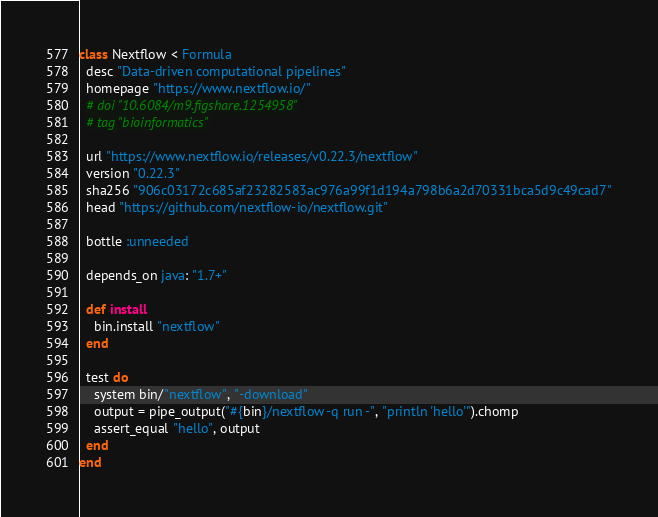<code> <loc_0><loc_0><loc_500><loc_500><_Ruby_>class Nextflow < Formula
  desc "Data-driven computational pipelines"
  homepage "https://www.nextflow.io/"
  # doi "10.6084/m9.figshare.1254958"
  # tag "bioinformatics"

  url "https://www.nextflow.io/releases/v0.22.3/nextflow"
  version "0.22.3"
  sha256 "906c03172c685af23282583ac976a99f1d194a798b6a2d70331bca5d9c49cad7"
  head "https://github.com/nextflow-io/nextflow.git"

  bottle :unneeded

  depends_on java: "1.7+"

  def install
    bin.install "nextflow"
  end

  test do
    system bin/"nextflow", "-download"
    output = pipe_output("#{bin}/nextflow -q run -", "println 'hello'").chomp
    assert_equal "hello", output
  end
end
</code> 